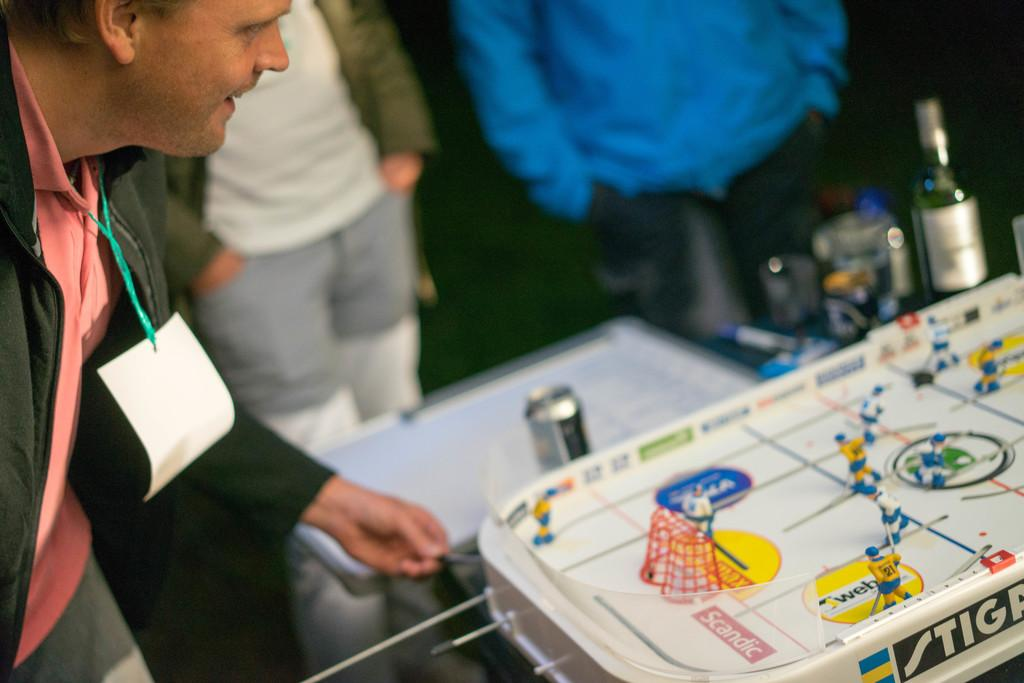What is the main subject of the image? There is a man standing in the image. Where is the man positioned in relation to the table? The man is standing in front of a table. What can be seen behind the table in the image? There are bottles behind the table in the image. What type of curve can be seen in the man's self-portrait in the image? There is no self-portrait present in the image, and therefore no curve can be observed. 